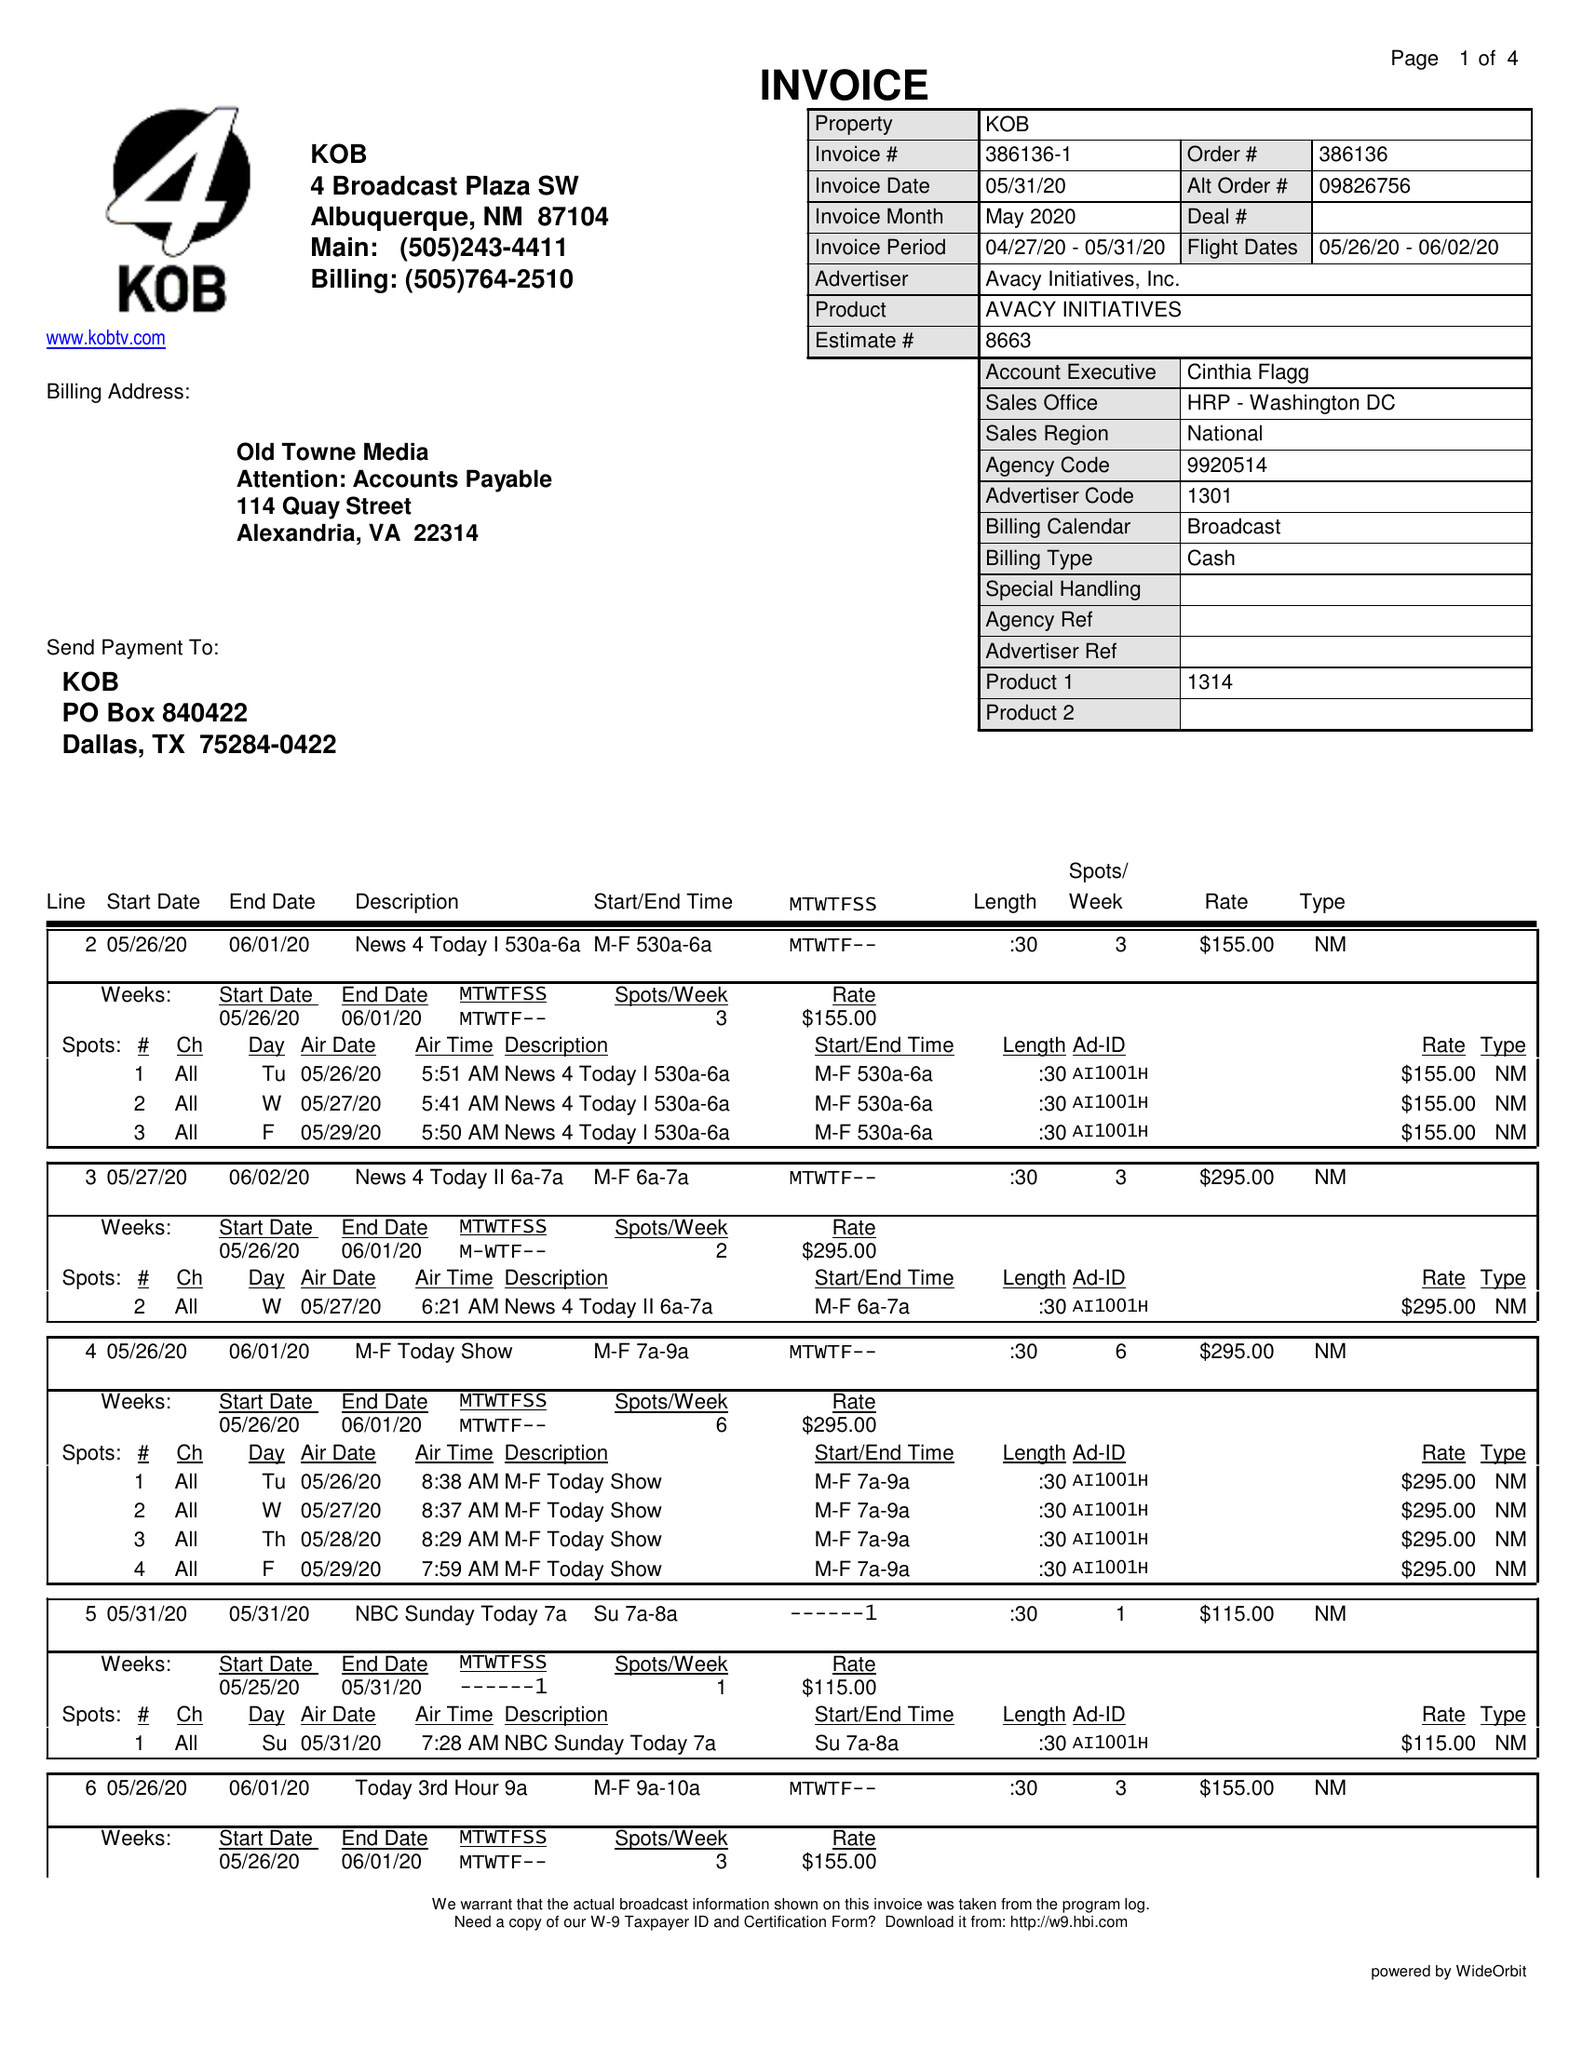What is the value for the flight_to?
Answer the question using a single word or phrase. 06/02/20 